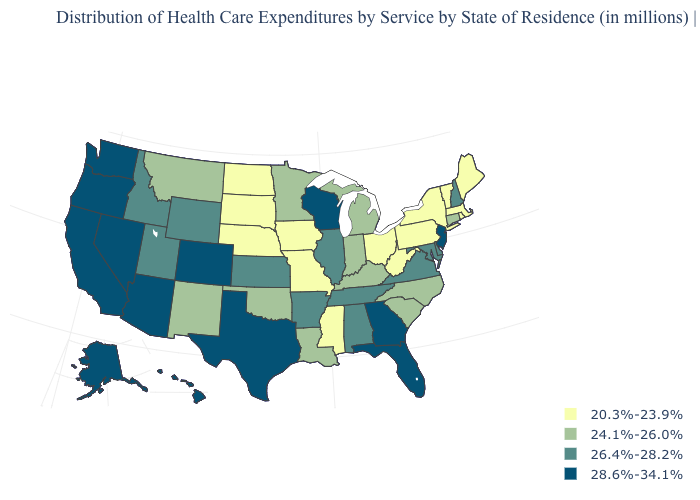What is the value of Utah?
Give a very brief answer. 26.4%-28.2%. Is the legend a continuous bar?
Be succinct. No. Does Nevada have the same value as Alaska?
Concise answer only. Yes. What is the lowest value in the West?
Concise answer only. 24.1%-26.0%. Name the states that have a value in the range 26.4%-28.2%?
Short answer required. Alabama, Arkansas, Delaware, Idaho, Illinois, Kansas, Maryland, New Hampshire, Tennessee, Utah, Virginia, Wyoming. What is the lowest value in the MidWest?
Write a very short answer. 20.3%-23.9%. Among the states that border Idaho , does Oregon have the highest value?
Be succinct. Yes. Does the map have missing data?
Be succinct. No. Name the states that have a value in the range 20.3%-23.9%?
Quick response, please. Iowa, Maine, Massachusetts, Mississippi, Missouri, Nebraska, New York, North Dakota, Ohio, Pennsylvania, Rhode Island, South Dakota, Vermont, West Virginia. Name the states that have a value in the range 28.6%-34.1%?
Short answer required. Alaska, Arizona, California, Colorado, Florida, Georgia, Hawaii, Nevada, New Jersey, Oregon, Texas, Washington, Wisconsin. Does Texas have the highest value in the South?
Answer briefly. Yes. Name the states that have a value in the range 26.4%-28.2%?
Be succinct. Alabama, Arkansas, Delaware, Idaho, Illinois, Kansas, Maryland, New Hampshire, Tennessee, Utah, Virginia, Wyoming. Does Mississippi have the lowest value in the USA?
Quick response, please. Yes. Which states have the lowest value in the USA?
Keep it brief. Iowa, Maine, Massachusetts, Mississippi, Missouri, Nebraska, New York, North Dakota, Ohio, Pennsylvania, Rhode Island, South Dakota, Vermont, West Virginia. 